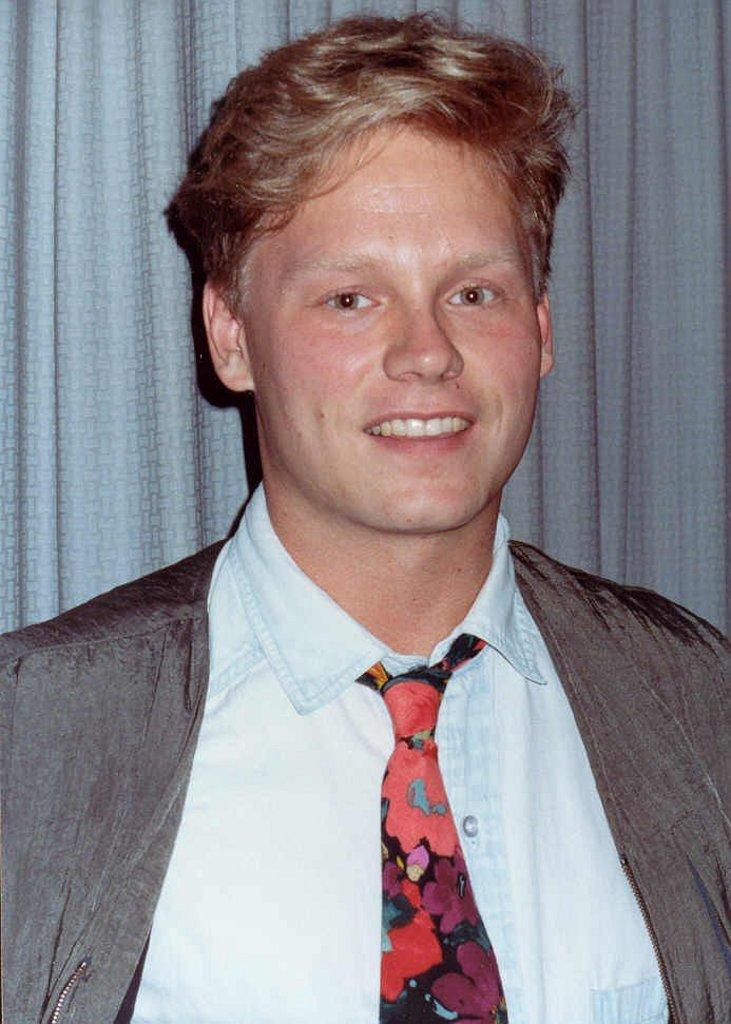What is the main subject of the image? There is a man standing in the image. Can you describe the man's attire? The man is wearing a coat and a tie. What can be seen in the background of the image? There is a curtain in the background of the image. What type of hat is the man wearing in the image? The man is not wearing a hat in the image. What hobbies can be seen being performed by the man in the image? There is no indication of any hobbies being performed by the man in the image. 